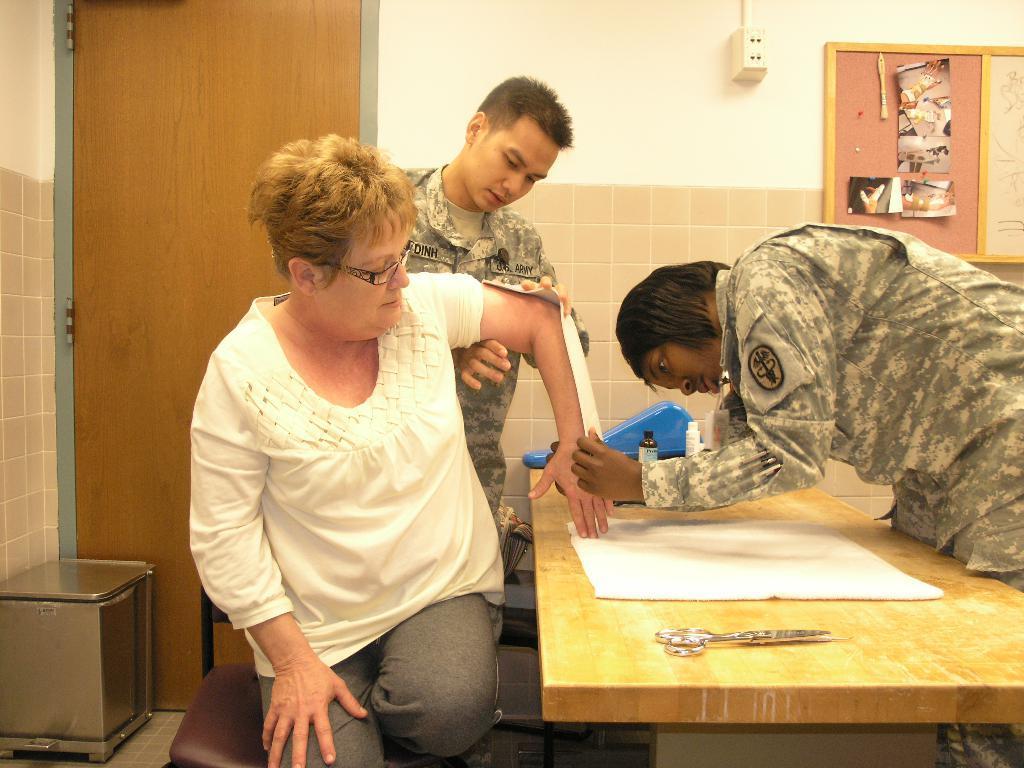Can you describe this image briefly? This picture describes about three people in front of them we can see a scissor, paper and some objects on the table besides to them we can find box, notice boards and socket. 